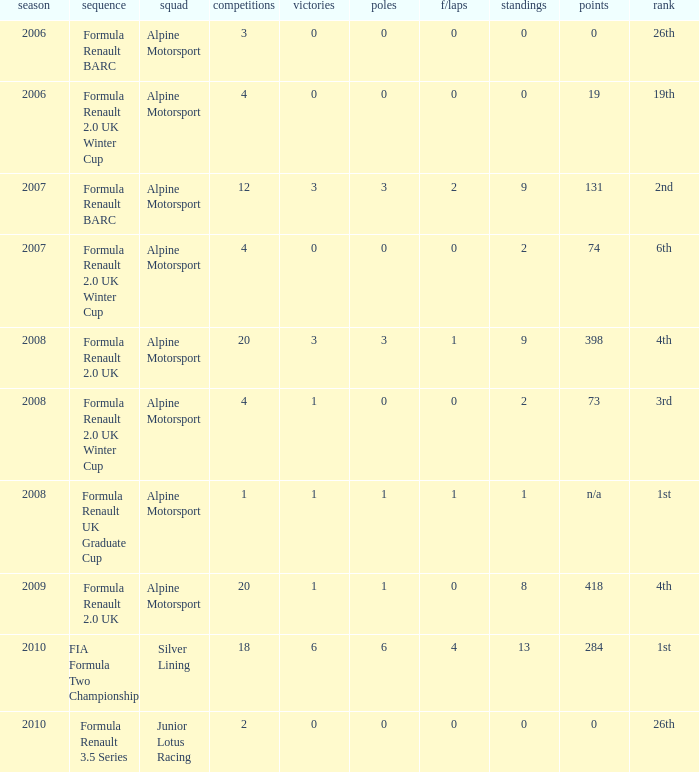How much were the f/laps if poles is higher than 1.0 during 2008? 1.0. 